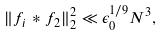Convert formula to latex. <formula><loc_0><loc_0><loc_500><loc_500>\| f _ { i } * f _ { 2 } \| ^ { 2 } _ { 2 } \ll \epsilon _ { 0 } ^ { 1 / 9 } N ^ { 3 } ,</formula> 